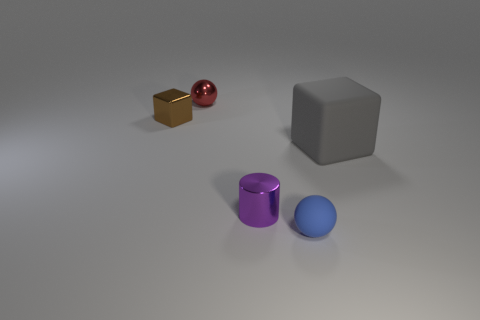Add 1 small brown metal spheres. How many objects exist? 6 Add 5 shiny things. How many shiny things are left? 8 Add 1 gray rubber things. How many gray rubber things exist? 2 Subtract all red spheres. How many spheres are left? 1 Subtract 0 cyan balls. How many objects are left? 5 Subtract all balls. How many objects are left? 3 Subtract 2 spheres. How many spheres are left? 0 Subtract all gray cubes. Subtract all blue cylinders. How many cubes are left? 1 Subtract all large cyan metallic cylinders. Subtract all blue balls. How many objects are left? 4 